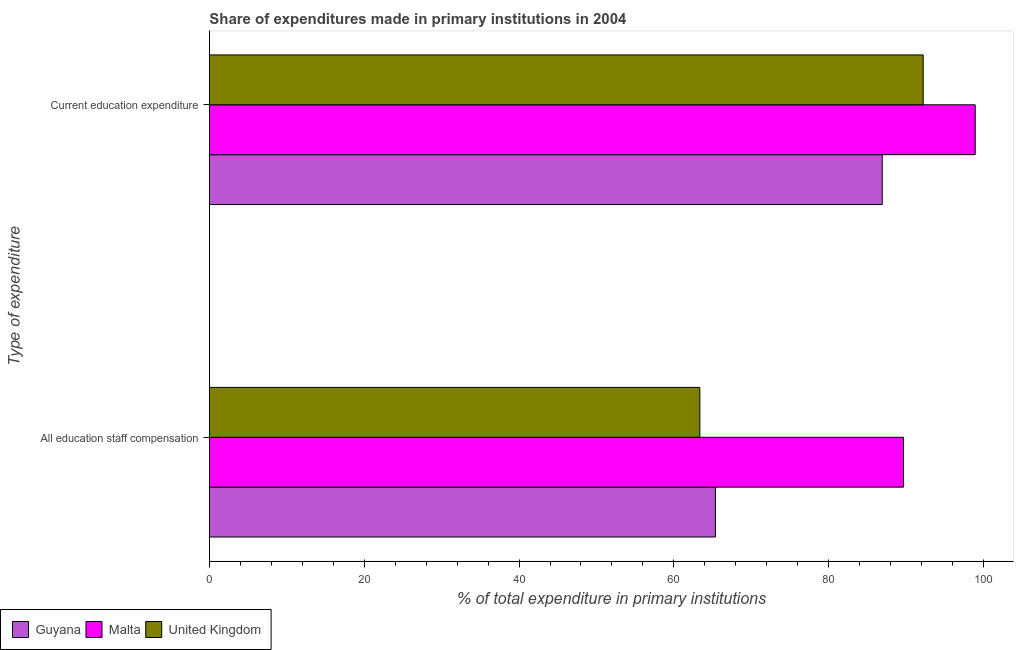How many groups of bars are there?
Offer a terse response. 2. Are the number of bars on each tick of the Y-axis equal?
Provide a succinct answer. Yes. How many bars are there on the 2nd tick from the bottom?
Offer a terse response. 3. What is the label of the 1st group of bars from the top?
Offer a terse response. Current education expenditure. What is the expenditure in staff compensation in United Kingdom?
Keep it short and to the point. 63.36. Across all countries, what is the maximum expenditure in education?
Keep it short and to the point. 98.93. Across all countries, what is the minimum expenditure in staff compensation?
Make the answer very short. 63.36. In which country was the expenditure in education maximum?
Make the answer very short. Malta. In which country was the expenditure in education minimum?
Offer a very short reply. Guyana. What is the total expenditure in education in the graph?
Offer a very short reply. 278.06. What is the difference between the expenditure in education in United Kingdom and that in Malta?
Provide a succinct answer. -6.72. What is the difference between the expenditure in education in United Kingdom and the expenditure in staff compensation in Malta?
Your answer should be very brief. 2.55. What is the average expenditure in staff compensation per country?
Keep it short and to the point. 72.8. What is the difference between the expenditure in staff compensation and expenditure in education in United Kingdom?
Make the answer very short. -28.85. What is the ratio of the expenditure in staff compensation in Guyana to that in United Kingdom?
Give a very brief answer. 1.03. What does the 2nd bar from the bottom in Current education expenditure represents?
Ensure brevity in your answer.  Malta. How many bars are there?
Your answer should be compact. 6. Are all the bars in the graph horizontal?
Provide a short and direct response. Yes. How many countries are there in the graph?
Give a very brief answer. 3. Are the values on the major ticks of X-axis written in scientific E-notation?
Offer a terse response. No. Does the graph contain any zero values?
Your response must be concise. No. How many legend labels are there?
Your answer should be very brief. 3. How are the legend labels stacked?
Your answer should be very brief. Horizontal. What is the title of the graph?
Provide a short and direct response. Share of expenditures made in primary institutions in 2004. Does "Afghanistan" appear as one of the legend labels in the graph?
Offer a very short reply. No. What is the label or title of the X-axis?
Provide a short and direct response. % of total expenditure in primary institutions. What is the label or title of the Y-axis?
Offer a terse response. Type of expenditure. What is the % of total expenditure in primary institutions of Guyana in All education staff compensation?
Provide a succinct answer. 65.37. What is the % of total expenditure in primary institutions of Malta in All education staff compensation?
Make the answer very short. 89.66. What is the % of total expenditure in primary institutions of United Kingdom in All education staff compensation?
Offer a very short reply. 63.36. What is the % of total expenditure in primary institutions of Guyana in Current education expenditure?
Provide a short and direct response. 86.92. What is the % of total expenditure in primary institutions in Malta in Current education expenditure?
Offer a very short reply. 98.93. What is the % of total expenditure in primary institutions in United Kingdom in Current education expenditure?
Offer a very short reply. 92.21. Across all Type of expenditure, what is the maximum % of total expenditure in primary institutions in Guyana?
Your answer should be very brief. 86.92. Across all Type of expenditure, what is the maximum % of total expenditure in primary institutions in Malta?
Offer a terse response. 98.93. Across all Type of expenditure, what is the maximum % of total expenditure in primary institutions of United Kingdom?
Provide a succinct answer. 92.21. Across all Type of expenditure, what is the minimum % of total expenditure in primary institutions of Guyana?
Offer a very short reply. 65.37. Across all Type of expenditure, what is the minimum % of total expenditure in primary institutions in Malta?
Provide a succinct answer. 89.66. Across all Type of expenditure, what is the minimum % of total expenditure in primary institutions of United Kingdom?
Make the answer very short. 63.36. What is the total % of total expenditure in primary institutions in Guyana in the graph?
Your response must be concise. 152.29. What is the total % of total expenditure in primary institutions in Malta in the graph?
Provide a short and direct response. 188.59. What is the total % of total expenditure in primary institutions in United Kingdom in the graph?
Give a very brief answer. 155.57. What is the difference between the % of total expenditure in primary institutions of Guyana in All education staff compensation and that in Current education expenditure?
Your response must be concise. -21.55. What is the difference between the % of total expenditure in primary institutions of Malta in All education staff compensation and that in Current education expenditure?
Keep it short and to the point. -9.27. What is the difference between the % of total expenditure in primary institutions in United Kingdom in All education staff compensation and that in Current education expenditure?
Your answer should be compact. -28.85. What is the difference between the % of total expenditure in primary institutions of Guyana in All education staff compensation and the % of total expenditure in primary institutions of Malta in Current education expenditure?
Offer a terse response. -33.56. What is the difference between the % of total expenditure in primary institutions of Guyana in All education staff compensation and the % of total expenditure in primary institutions of United Kingdom in Current education expenditure?
Your answer should be compact. -26.84. What is the difference between the % of total expenditure in primary institutions in Malta in All education staff compensation and the % of total expenditure in primary institutions in United Kingdom in Current education expenditure?
Your answer should be compact. -2.55. What is the average % of total expenditure in primary institutions of Guyana per Type of expenditure?
Ensure brevity in your answer.  76.14. What is the average % of total expenditure in primary institutions of Malta per Type of expenditure?
Your answer should be very brief. 94.3. What is the average % of total expenditure in primary institutions in United Kingdom per Type of expenditure?
Your answer should be very brief. 77.78. What is the difference between the % of total expenditure in primary institutions in Guyana and % of total expenditure in primary institutions in Malta in All education staff compensation?
Make the answer very short. -24.29. What is the difference between the % of total expenditure in primary institutions in Guyana and % of total expenditure in primary institutions in United Kingdom in All education staff compensation?
Give a very brief answer. 2.01. What is the difference between the % of total expenditure in primary institutions of Malta and % of total expenditure in primary institutions of United Kingdom in All education staff compensation?
Provide a short and direct response. 26.31. What is the difference between the % of total expenditure in primary institutions of Guyana and % of total expenditure in primary institutions of Malta in Current education expenditure?
Ensure brevity in your answer.  -12.01. What is the difference between the % of total expenditure in primary institutions in Guyana and % of total expenditure in primary institutions in United Kingdom in Current education expenditure?
Give a very brief answer. -5.29. What is the difference between the % of total expenditure in primary institutions in Malta and % of total expenditure in primary institutions in United Kingdom in Current education expenditure?
Your answer should be compact. 6.72. What is the ratio of the % of total expenditure in primary institutions of Guyana in All education staff compensation to that in Current education expenditure?
Your answer should be compact. 0.75. What is the ratio of the % of total expenditure in primary institutions of Malta in All education staff compensation to that in Current education expenditure?
Your answer should be very brief. 0.91. What is the ratio of the % of total expenditure in primary institutions of United Kingdom in All education staff compensation to that in Current education expenditure?
Keep it short and to the point. 0.69. What is the difference between the highest and the second highest % of total expenditure in primary institutions of Guyana?
Provide a succinct answer. 21.55. What is the difference between the highest and the second highest % of total expenditure in primary institutions in Malta?
Your answer should be compact. 9.27. What is the difference between the highest and the second highest % of total expenditure in primary institutions in United Kingdom?
Provide a short and direct response. 28.85. What is the difference between the highest and the lowest % of total expenditure in primary institutions in Guyana?
Provide a short and direct response. 21.55. What is the difference between the highest and the lowest % of total expenditure in primary institutions in Malta?
Ensure brevity in your answer.  9.27. What is the difference between the highest and the lowest % of total expenditure in primary institutions in United Kingdom?
Provide a short and direct response. 28.85. 